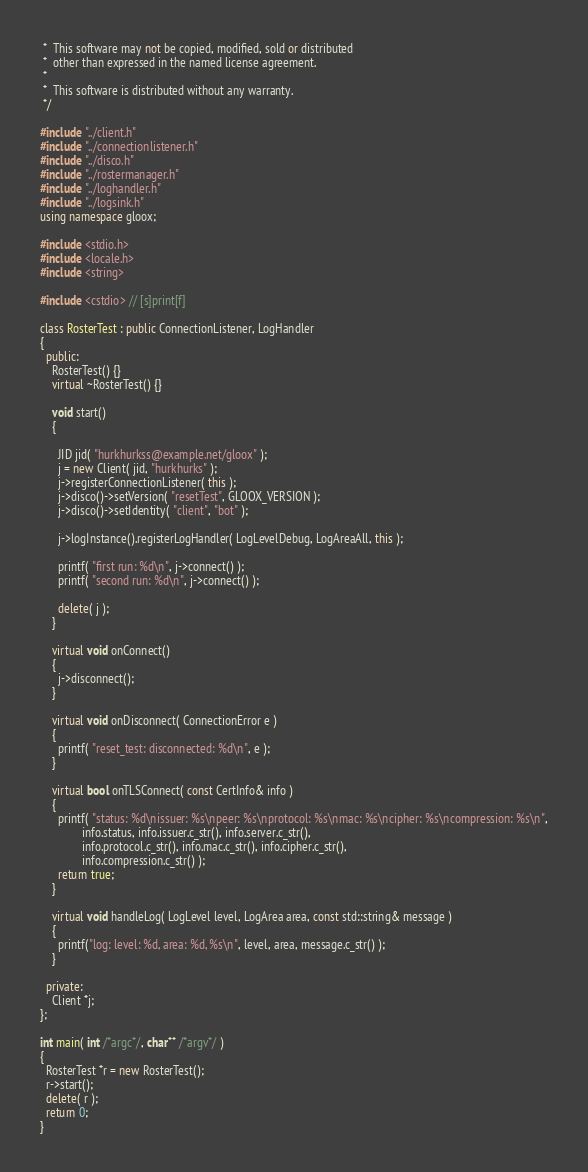<code> <loc_0><loc_0><loc_500><loc_500><_C++_> *  This software may not be copied, modified, sold or distributed
 *  other than expressed in the named license agreement.
 *
 *  This software is distributed without any warranty.
 */

#include "../client.h"
#include "../connectionlistener.h"
#include "../disco.h"
#include "../rostermanager.h"
#include "../loghandler.h"
#include "../logsink.h"
using namespace gloox;

#include <stdio.h>
#include <locale.h>
#include <string>

#include <cstdio> // [s]print[f]

class RosterTest : public ConnectionListener, LogHandler
{
  public:
    RosterTest() {}
    virtual ~RosterTest() {}

    void start()
    {

      JID jid( "hurkhurkss@example.net/gloox" );
      j = new Client( jid, "hurkhurks" );
      j->registerConnectionListener( this );
      j->disco()->setVersion( "resetTest", GLOOX_VERSION );
      j->disco()->setIdentity( "client", "bot" );

      j->logInstance().registerLogHandler( LogLevelDebug, LogAreaAll, this );

      printf( "first run: %d\n", j->connect() );
      printf( "second run: %d\n", j->connect() );

      delete( j );
    }

    virtual void onConnect()
    {
      j->disconnect();
    }

    virtual void onDisconnect( ConnectionError e )
    {
      printf( "reset_test: disconnected: %d\n", e );
    }

    virtual bool onTLSConnect( const CertInfo& info )
    {
      printf( "status: %d\nissuer: %s\npeer: %s\nprotocol: %s\nmac: %s\ncipher: %s\ncompression: %s\n",
              info.status, info.issuer.c_str(), info.server.c_str(),
              info.protocol.c_str(), info.mac.c_str(), info.cipher.c_str(),
              info.compression.c_str() );
      return true;
    }

    virtual void handleLog( LogLevel level, LogArea area, const std::string& message )
    {
      printf("log: level: %d, area: %d, %s\n", level, area, message.c_str() );
    }

  private:
    Client *j;
};

int main( int /*argc*/, char** /*argv*/ )
{
  RosterTest *r = new RosterTest();
  r->start();
  delete( r );
  return 0;
}
</code> 